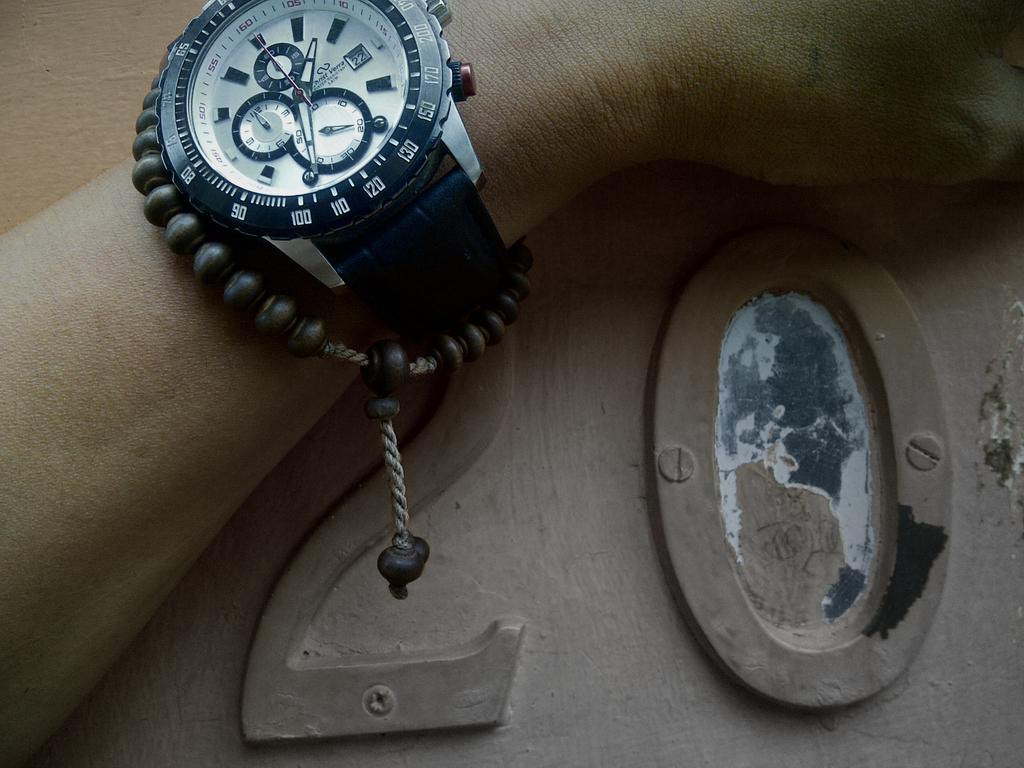<image>
Share a concise interpretation of the image provided. A watch displays the date of the 22nd atop a metal counter with the number 20 on it. 